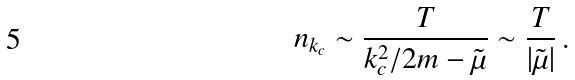<formula> <loc_0><loc_0><loc_500><loc_500>n _ { k _ { c } } \sim \frac { T } { k _ { c } ^ { 2 } / 2 m - \tilde { \mu } } \sim \frac { T } { | \tilde { \mu } | } \, .</formula> 